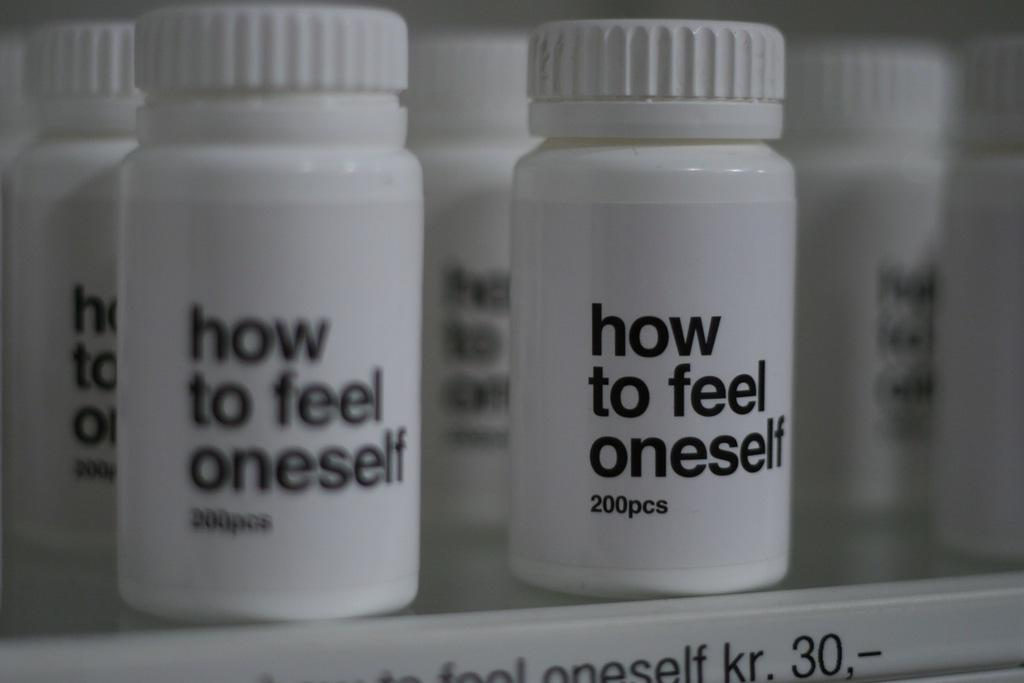<image>
Present a compact description of the photo's key features. White pill bottles with the words in black how to feel one self 200 pcs. 